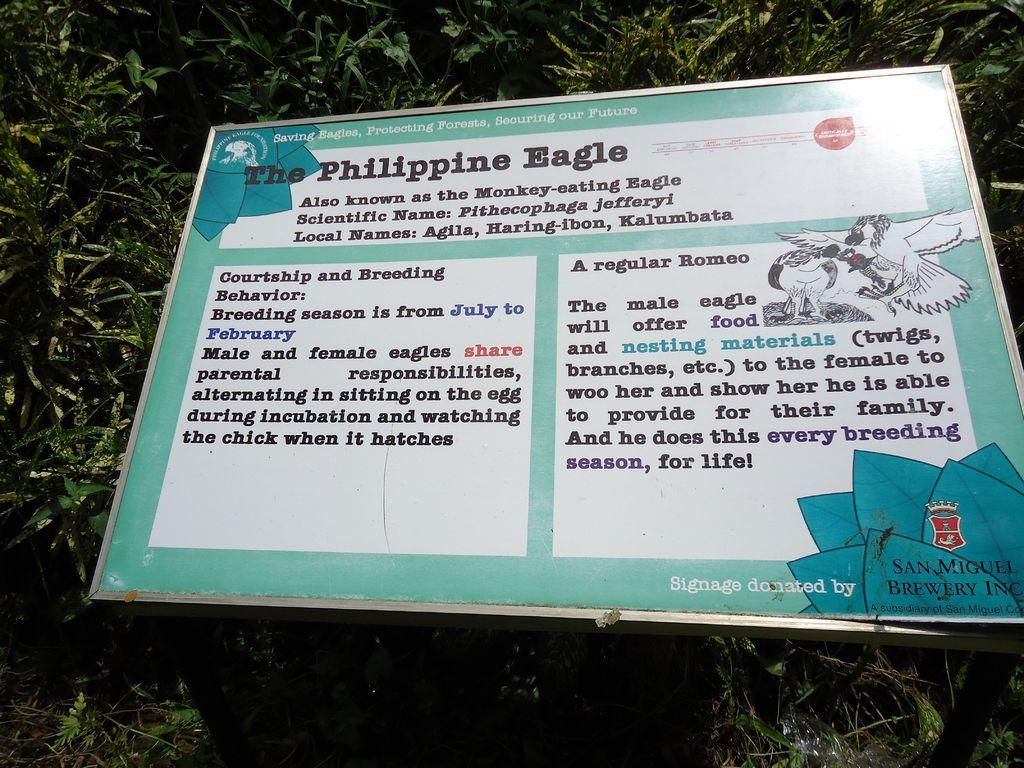What type of living organisms can be seen in the image? Plants can be seen in the image. What object is present in the image besides the plants? There is a board in the image. What is featured on the board? Something is written on the board, and there is a depiction of birds on the right side of the board. What type of bell can be seen hanging from the sock in the image? There is no bell or sock present in the image. 